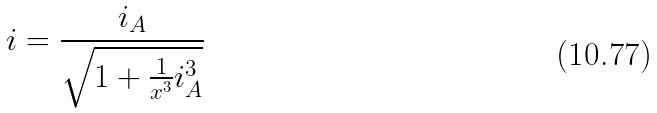Convert formula to latex. <formula><loc_0><loc_0><loc_500><loc_500>i = \frac { i _ { A } } { \sqrt { 1 + \frac { 1 } { x ^ { 3 } } i _ { A } ^ { 3 } } }</formula> 